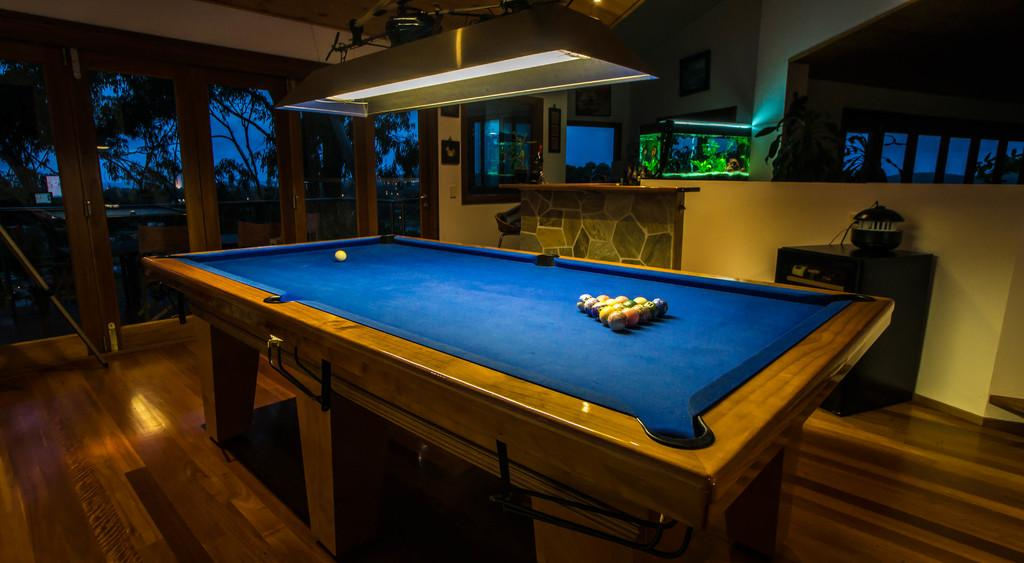What type of furniture is present in the image? There is a table, chairs, and cupboards in the image. What objects are on the table? There are balls on the table. What can be seen through the windows in the image? Trees and the sky are visible through the windows. What type of lighting is present in the image? There is a light in the image. Is there any living creature or pet in the image? No, there is no living creature or pet visible in the image. How many horses are visible in the image? There are no horses present in the image. What type of stocking is the sister wearing in the image? There is no sister or stocking present in the image. 